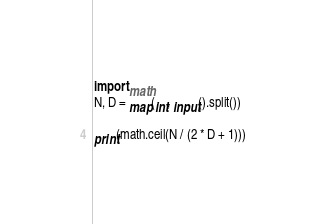Convert code to text. <code><loc_0><loc_0><loc_500><loc_500><_Python_>import math
N, D = map(int, input().split())

print(math.ceil(N / (2 * D + 1)))
</code> 